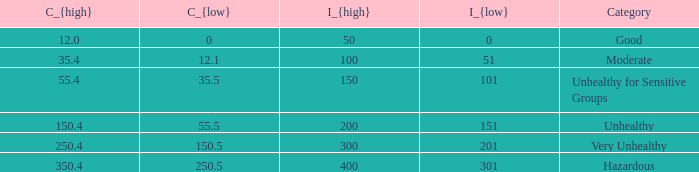In how many different categories is the value of C_{low} 35.5? 1.0. 